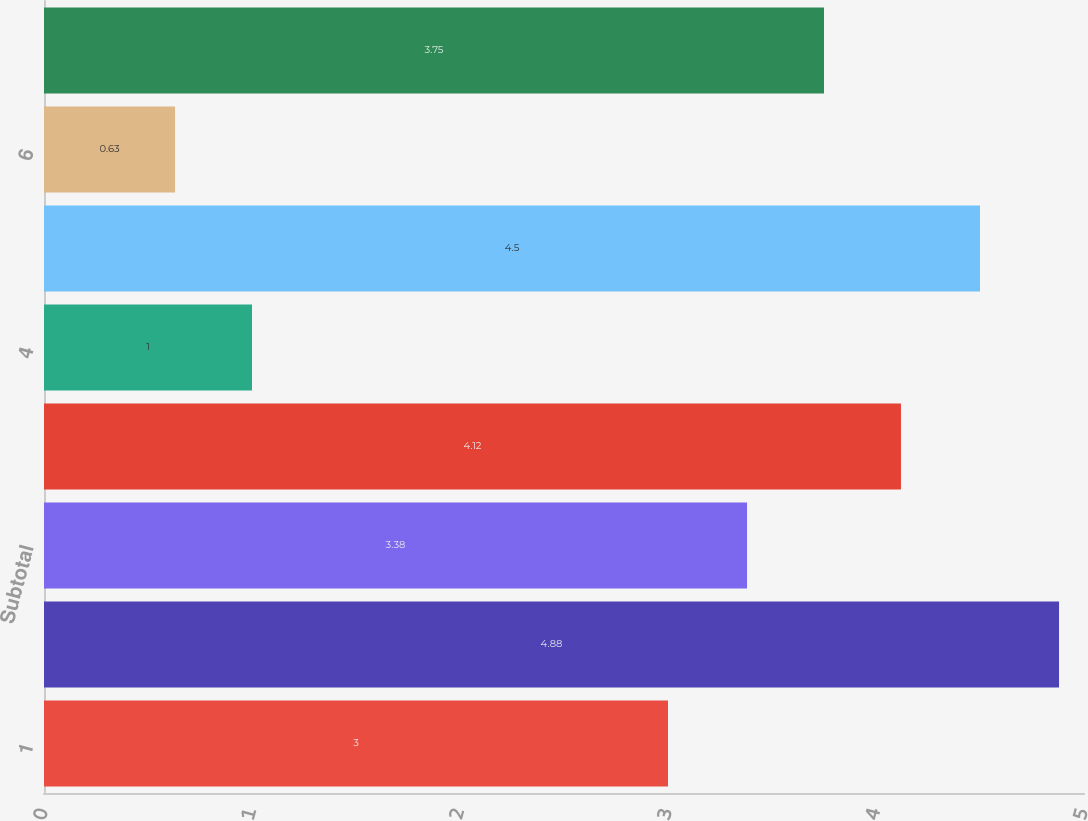Convert chart to OTSL. <chart><loc_0><loc_0><loc_500><loc_500><bar_chart><fcel>1<fcel>2<fcel>Subtotal<fcel>3<fcel>4<fcel>5<fcel>6<fcel>Total<nl><fcel>3<fcel>4.88<fcel>3.38<fcel>4.12<fcel>1<fcel>4.5<fcel>0.63<fcel>3.75<nl></chart> 